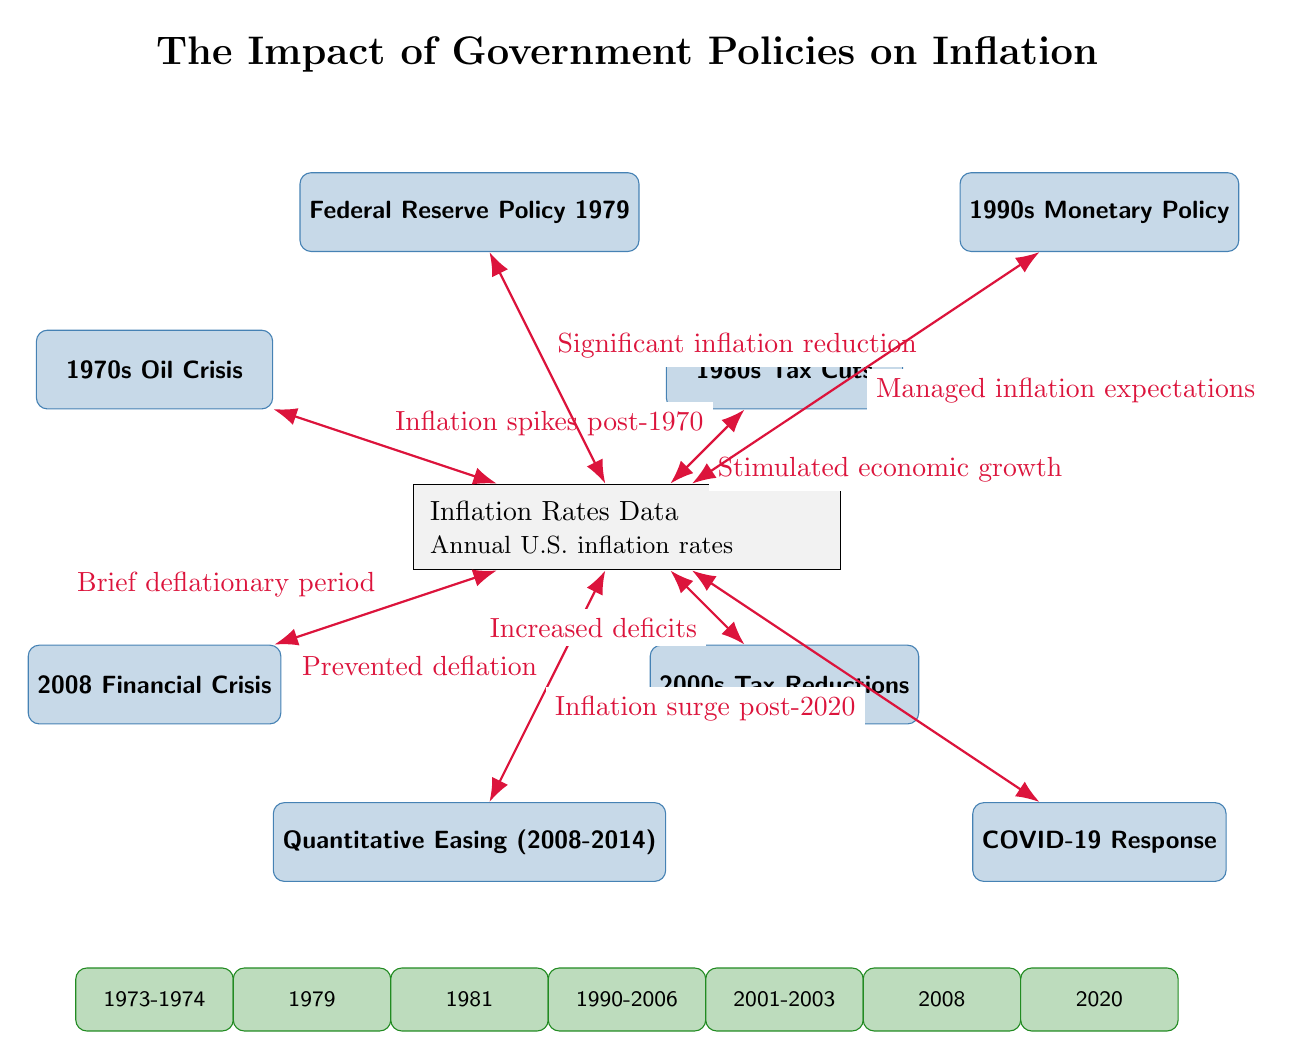What event is associated with significant inflation reduction? The diagram indicates that the "Federal Reserve Policy 1979" led to a "Significant inflation reduction" as it connects with an arrow to the inflation rates data.
Answer: Federal Reserve Policy 1979 What is indicated as having prevented deflation? The connection from "Quantitative Easing (2008-2014)" leads to the inflation rates data with the phrase "Prevented deflation."
Answer: Prevented deflation How many significant events are listed above the inflation rates data? By counting the nodes (events) above the inflation rates data in the diagram, we find there are eight events connected to it.
Answer: Eight What is the timeline year for the 2008 Financial Crisis? The diagram shows that the event "2008 Financial Crisis" is placed at the timeline year marked as "2008."
Answer: 2008 What action is described as stimulating economic growth? The diagram connects "1980s Tax Cuts" to the inflation rates data, labeling it as "Stimulated economic growth."
Answer: Stimulated economic growth Which event is linked to an inflation surge post-2020? The connection from "COVID-19 Response" to the inflation data states "Inflation surge post-2020," indicating this event caused the surge.
Answer: Inflation surge post-2020 What was the economic state during the 2008 Financial Crisis according to the diagram? The diagram states that there was a "Brief deflationary period" connected to the 2008 Financial Crisis event as it leads to the inflation rates data.
Answer: Brief deflationary period Which two events are shown to have occurred in the 1980s? The diagram shows two events: "1980s Tax Cuts" and "Federal Reserve Policy 1979," which are both situated in the 1980s range on the timeline.
Answer: 1980s Tax Cuts and Federal Reserve Policy 1979 What does the arrow between the 1970s Oil Crisis and the inflation rates data indicate? The arrow from "1970s Oil Crisis" to the inflation rates data states "Inflation spikes post-1970," indicating a direct relationship between the event and inflation.
Answer: Inflation spikes post-1970 